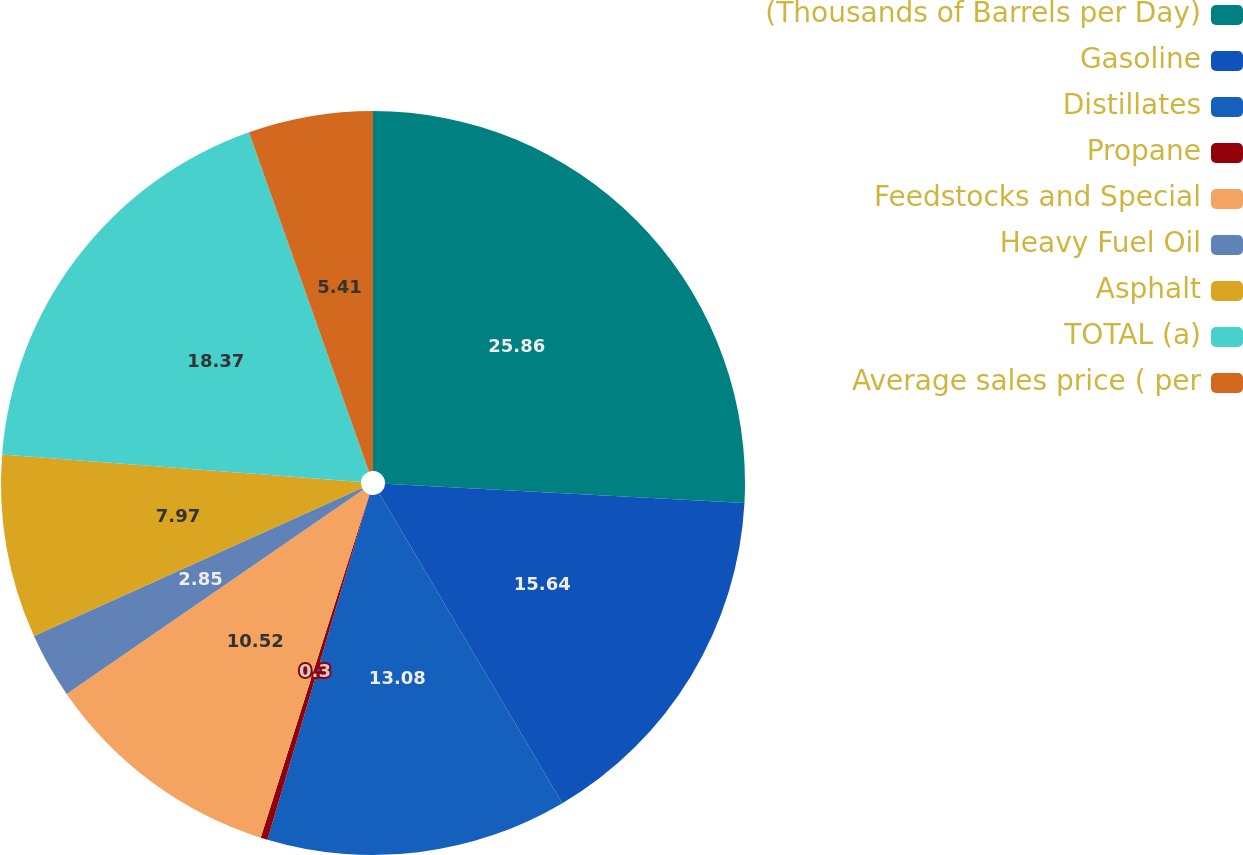Convert chart to OTSL. <chart><loc_0><loc_0><loc_500><loc_500><pie_chart><fcel>(Thousands of Barrels per Day)<fcel>Gasoline<fcel>Distillates<fcel>Propane<fcel>Feedstocks and Special<fcel>Heavy Fuel Oil<fcel>Asphalt<fcel>TOTAL (a)<fcel>Average sales price ( per<nl><fcel>25.86%<fcel>15.64%<fcel>13.08%<fcel>0.3%<fcel>10.52%<fcel>2.85%<fcel>7.97%<fcel>18.37%<fcel>5.41%<nl></chart> 